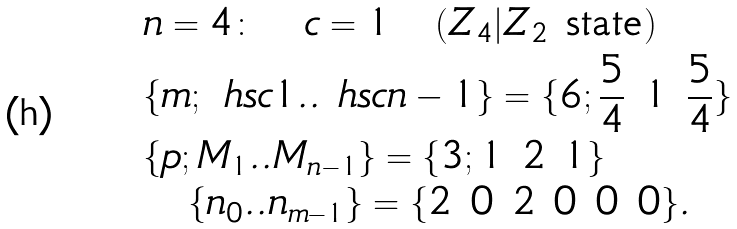Convert formula to latex. <formula><loc_0><loc_0><loc_500><loc_500>& n = 4 \colon \quad c = 1 \quad ( Z _ { 4 } | Z _ { 2 } \text { state} ) \\ & \{ m ; \ h s c { 1 } . . \ h s c { n - 1 } \} = \{ 6 ; \frac { 5 } { 4 } \ 1 \ \frac { 5 } { 4 } \} \\ & \{ p ; M _ { 1 } . . M _ { n - 1 } \} = \{ 3 ; 1 \ 2 \ 1 \} \\ & \quad \{ n _ { 0 } . . n _ { m - 1 } \} = \{ 2 \ 0 \ 2 \ 0 \ 0 \ 0 \} .</formula> 